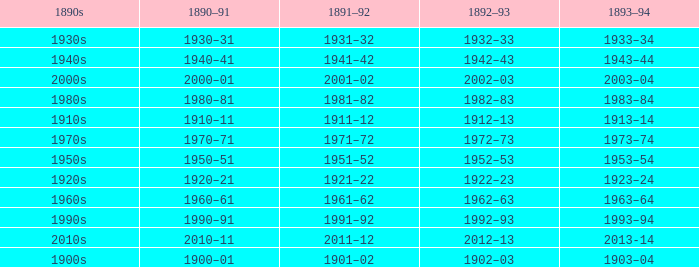What is the year from 1892-93 that has the 1890s to the 1940s? 1942–43. 